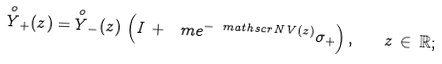Convert formula to latex. <formula><loc_0><loc_0><loc_500><loc_500>\overset { o } { Y } _ { + } ( z ) = \overset { o } { Y } _ { - } ( z ) \, \left ( I \, + \, \ m e ^ { - \ m a t h s c r { N } \, V ( z ) } \sigma _ { + } \right ) , \quad z \, \in \, \mathbb { R } ;</formula> 